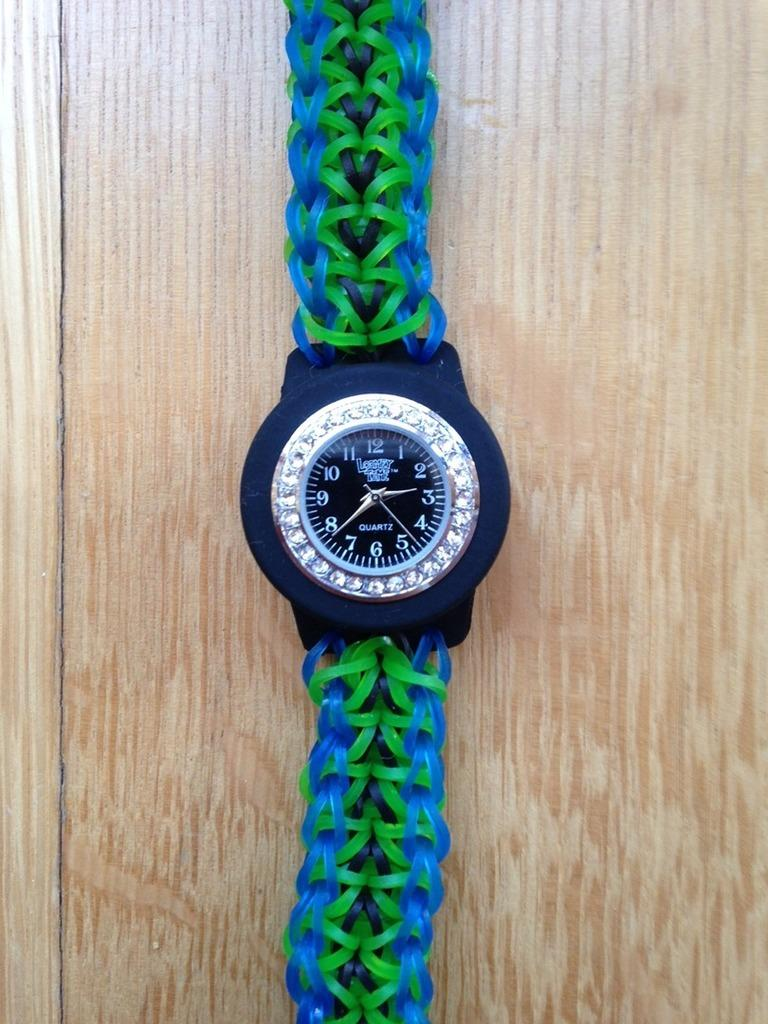<image>
Relay a brief, clear account of the picture shown. A Quartz watch with a band made out of rubber bands. 